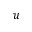<formula> <loc_0><loc_0><loc_500><loc_500>u</formula> 